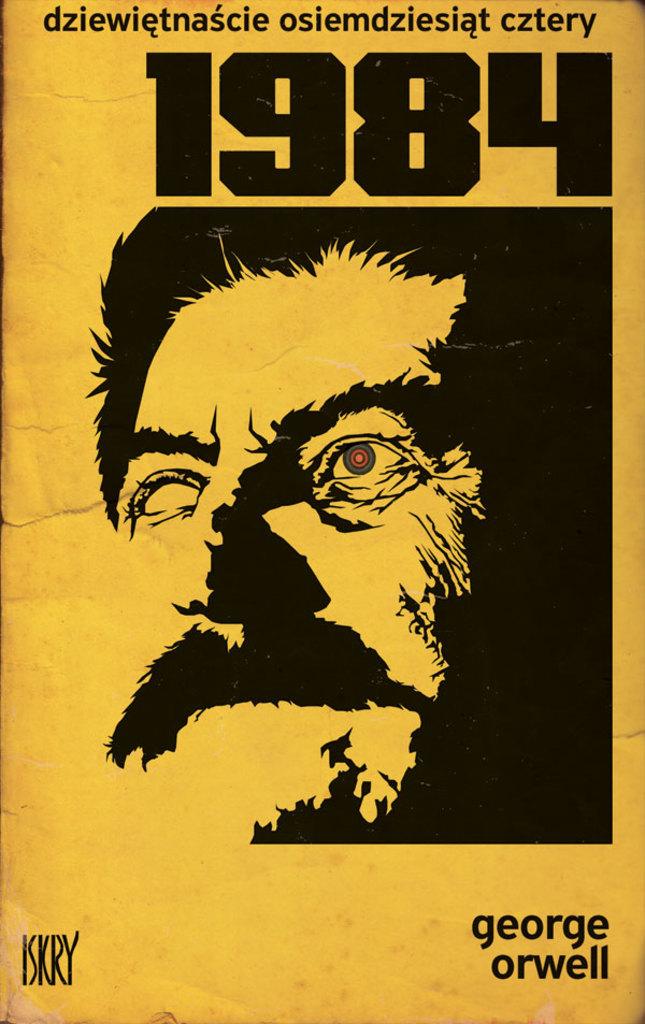Who wrote this book?
Give a very brief answer. George orwell. What's the title of the book?
Give a very brief answer. 1984. 